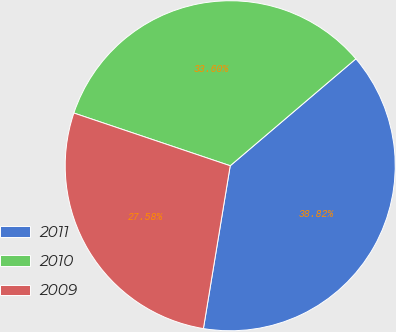Convert chart to OTSL. <chart><loc_0><loc_0><loc_500><loc_500><pie_chart><fcel>2011<fcel>2010<fcel>2009<nl><fcel>38.82%<fcel>33.6%<fcel>27.58%<nl></chart> 